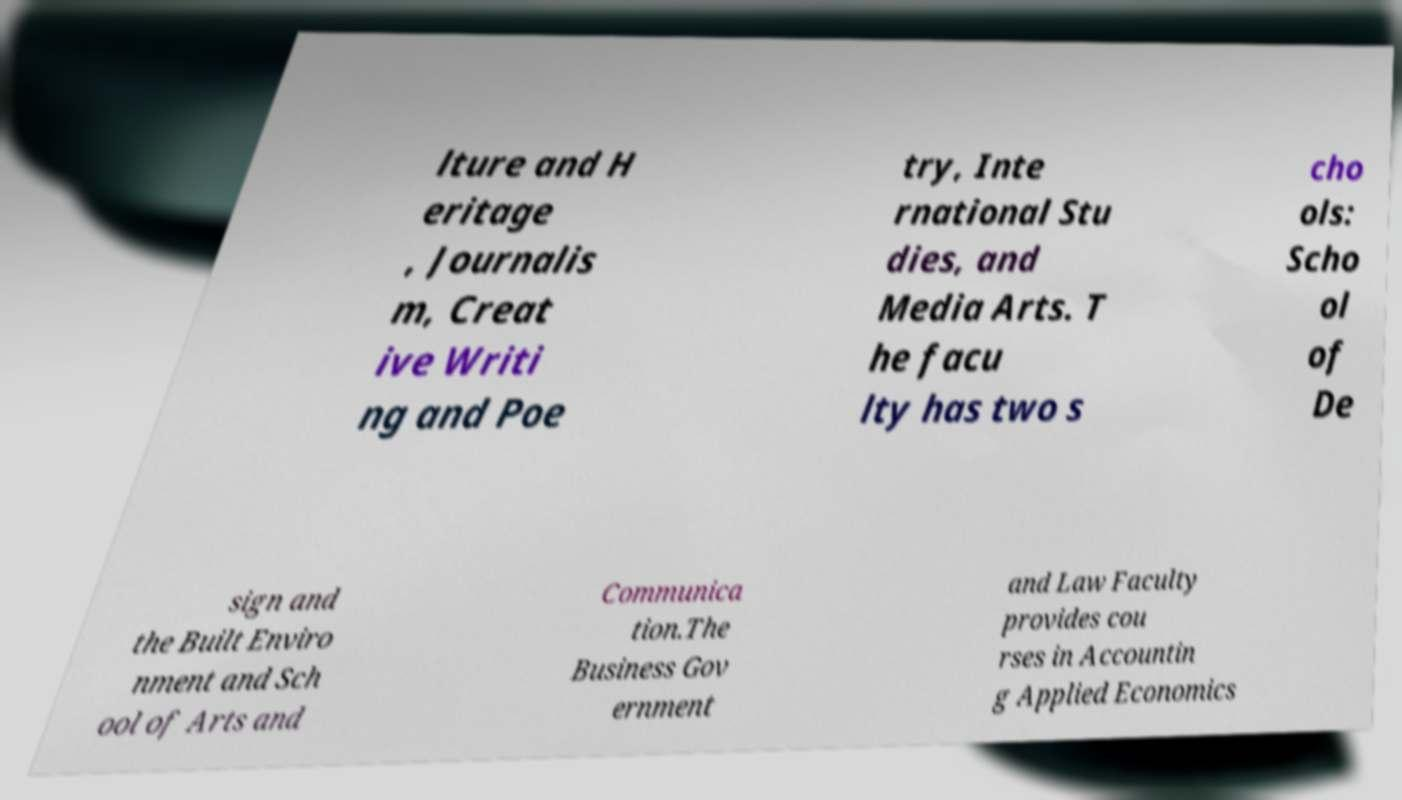There's text embedded in this image that I need extracted. Can you transcribe it verbatim? lture and H eritage , Journalis m, Creat ive Writi ng and Poe try, Inte rnational Stu dies, and Media Arts. T he facu lty has two s cho ols: Scho ol of De sign and the Built Enviro nment and Sch ool of Arts and Communica tion.The Business Gov ernment and Law Faculty provides cou rses in Accountin g Applied Economics 